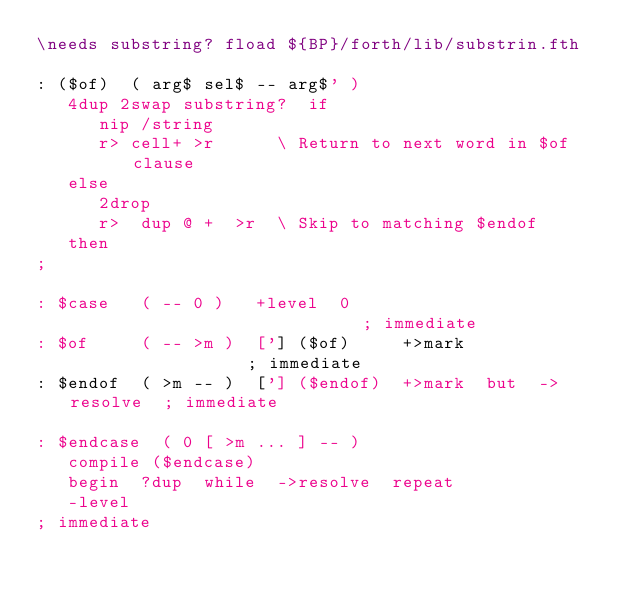<code> <loc_0><loc_0><loc_500><loc_500><_Forth_>\needs substring? fload ${BP}/forth/lib/substrin.fth

: ($of)  ( arg$ sel$ -- arg$' )
   4dup 2swap substring?  if
      nip /string
      r> cell+ >r      \ Return to next word in $of clause
   else
      2drop
      r>  dup @ +  >r  \ Skip to matching $endof
   then
;

: $case   ( -- 0 )   +level  0                             ; immediate
: $of     ( -- >m )  ['] ($of)     +>mark                  ; immediate
: $endof  ( >m -- )  ['] ($endof)  +>mark  but  ->resolve  ; immediate

: $endcase  ( 0 [ >m ... ] -- )
   compile ($endcase)
   begin  ?dup  while  ->resolve  repeat
   -level
; immediate

</code> 